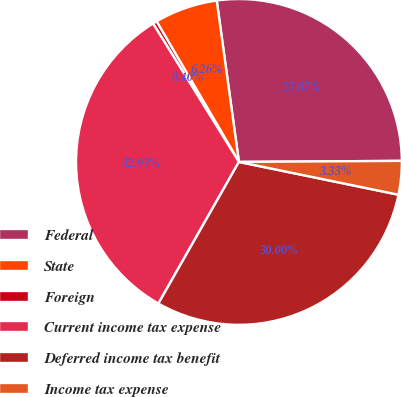Convert chart to OTSL. <chart><loc_0><loc_0><loc_500><loc_500><pie_chart><fcel>Federal<fcel>State<fcel>Foreign<fcel>Current income tax expense<fcel>Deferred income tax benefit<fcel>Income tax expense<nl><fcel>27.07%<fcel>6.26%<fcel>0.4%<fcel>32.93%<fcel>30.0%<fcel>3.33%<nl></chart> 